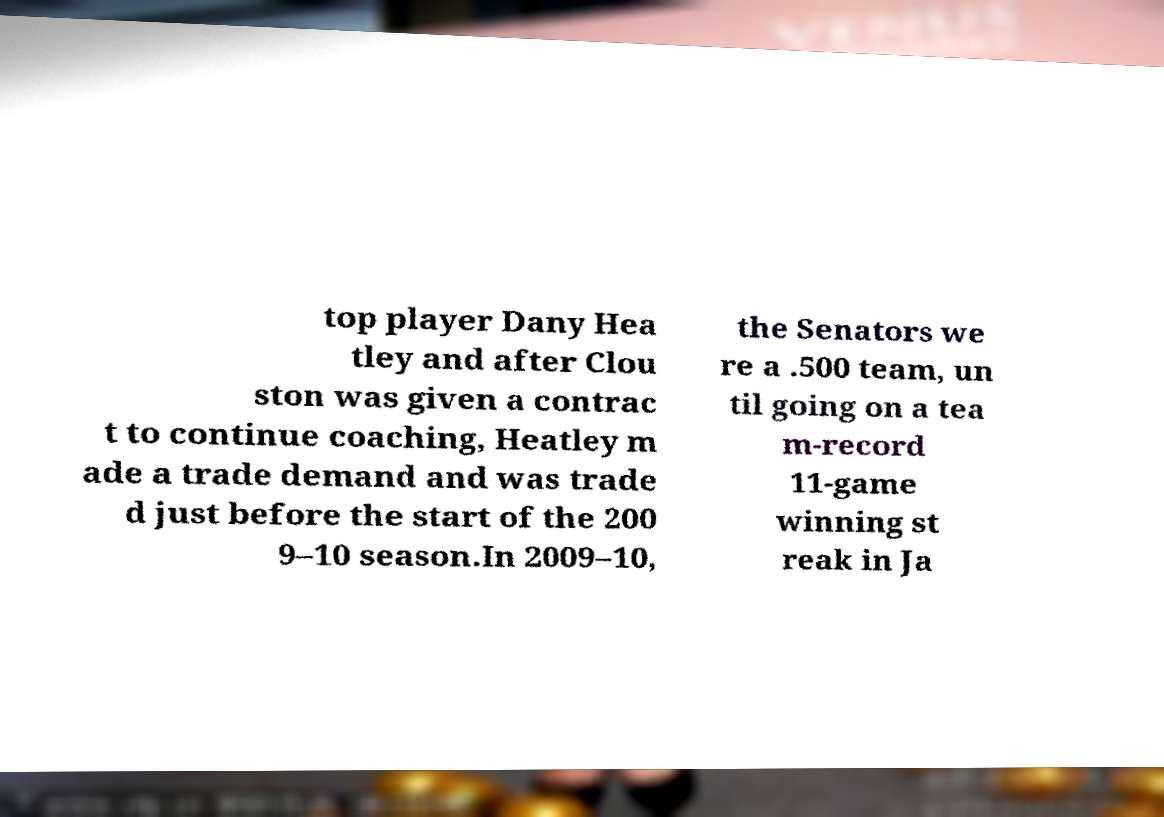Could you assist in decoding the text presented in this image and type it out clearly? top player Dany Hea tley and after Clou ston was given a contrac t to continue coaching, Heatley m ade a trade demand and was trade d just before the start of the 200 9–10 season.In 2009–10, the Senators we re a .500 team, un til going on a tea m-record 11-game winning st reak in Ja 